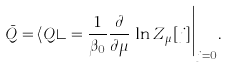<formula> <loc_0><loc_0><loc_500><loc_500>\bar { Q } = \langle Q \rangle = \frac { 1 } { \beta _ { 0 } } \frac { \partial } { \partial \mu } \, \ln Z _ { \mu } [ j ] \Big | _ { j = 0 } .</formula> 